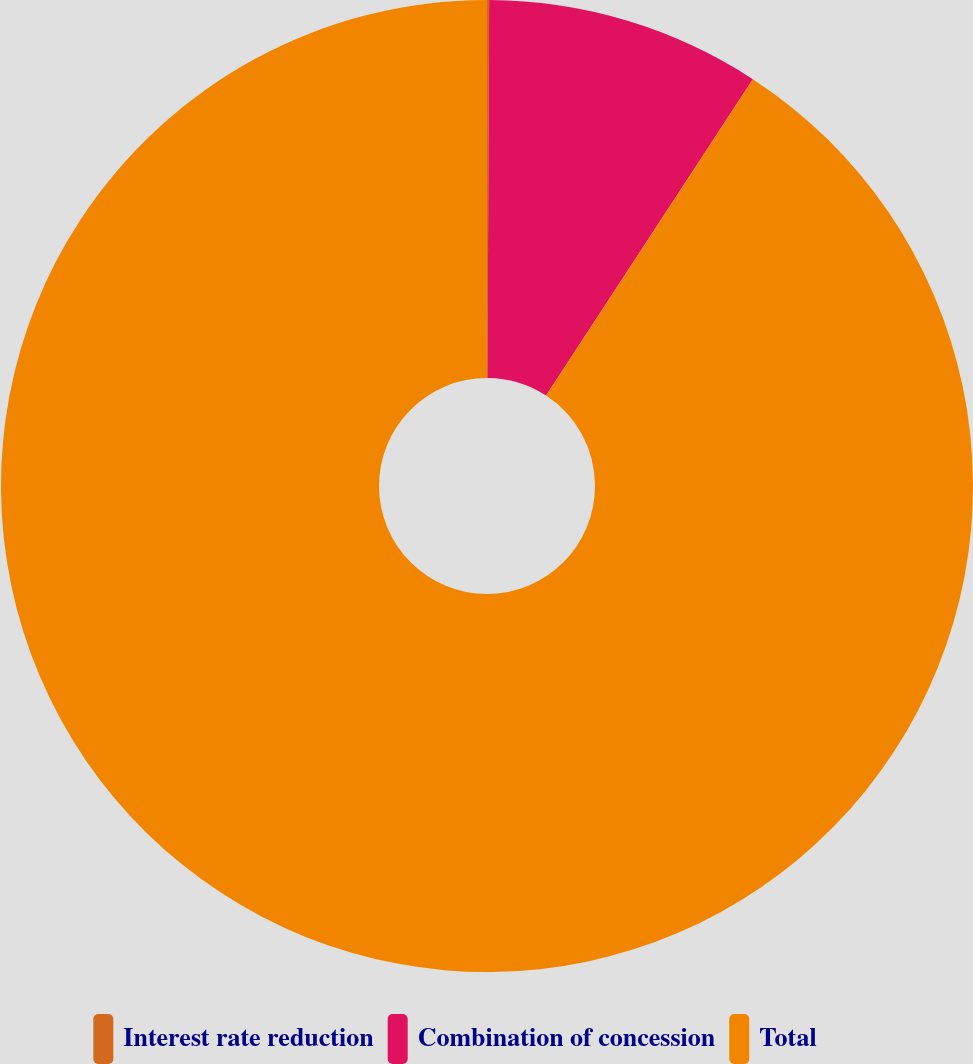Convert chart to OTSL. <chart><loc_0><loc_0><loc_500><loc_500><pie_chart><fcel>Interest rate reduction<fcel>Combination of concession<fcel>Total<nl><fcel>0.07%<fcel>9.14%<fcel>90.78%<nl></chart> 